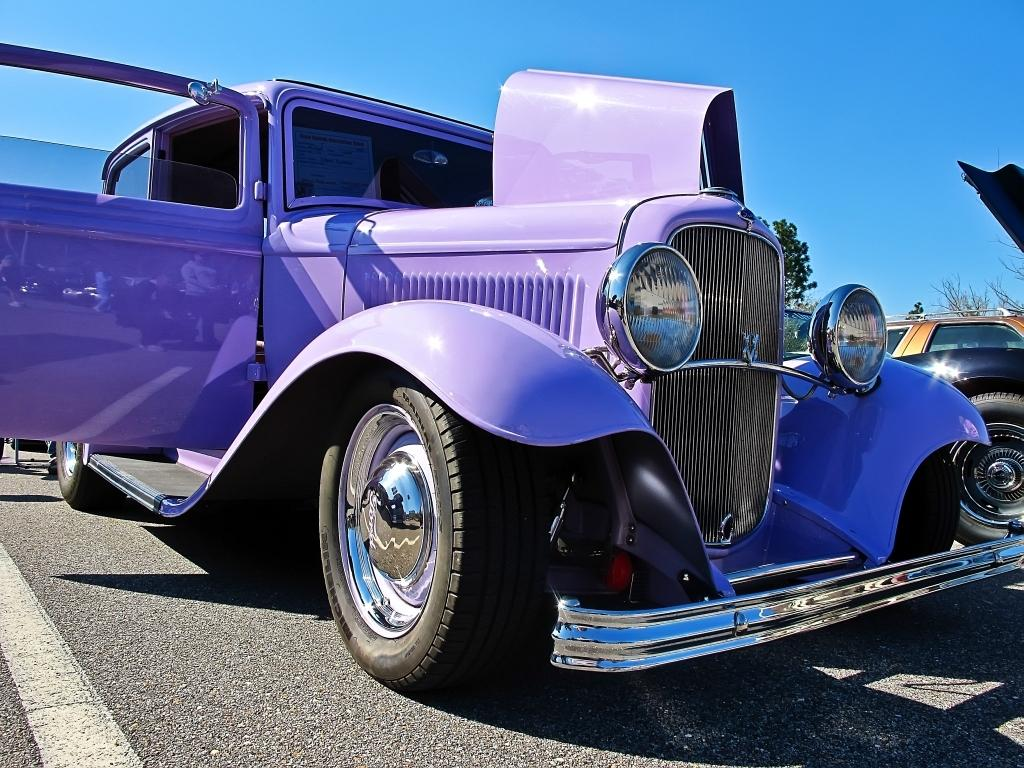What types of objects can be seen in the image? There are vehicles in the image. What natural elements are present in the image? Trees are present in the image. What is visible at the top of the image? The sky is visible at the top of the image. What surface can be seen at the bottom of the image? There is a road at the bottom of the image. What type of liquid is being burned in the image? There is no liquid being burned in the image; it does not depict any such activity. How many apples are hanging from the trees in the image? There are no apples present in the image; only vehicles, trees, and a road are visible. 